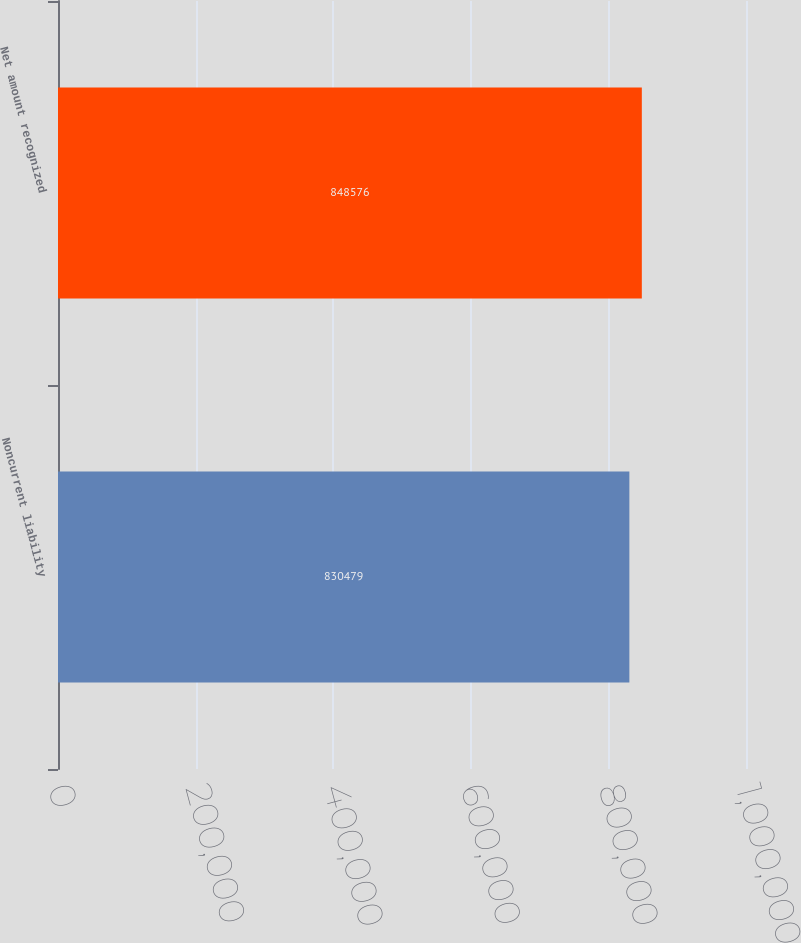Convert chart to OTSL. <chart><loc_0><loc_0><loc_500><loc_500><bar_chart><fcel>Noncurrent liability<fcel>Net amount recognized<nl><fcel>830479<fcel>848576<nl></chart> 